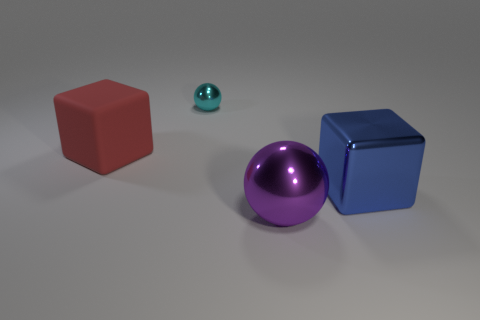What can you infer about the material properties of the objects? The objects seem to have different material properties. The red cube appears matte, suggesting a rubber-like material. The teal sphere has a shiny surface indicative of a metallic finish. Similarly, the purple sphere and the blue cube both exhibit reflective surfaces, which could imply they are made of metal as well. How can the reflections give us insights into the environment? The reflections seen on the shiny surfaces of the metallic objects provide subtle cues about the environment. For instance, the presence of soft shadows and diffuse reflections suggests that the objects are likely situated in a space with diffuse lighting, possibly from an overhead light source. There are no discernable specific details in the reflections, which indicates that the surrounding space may be relatively empty or featureless. 